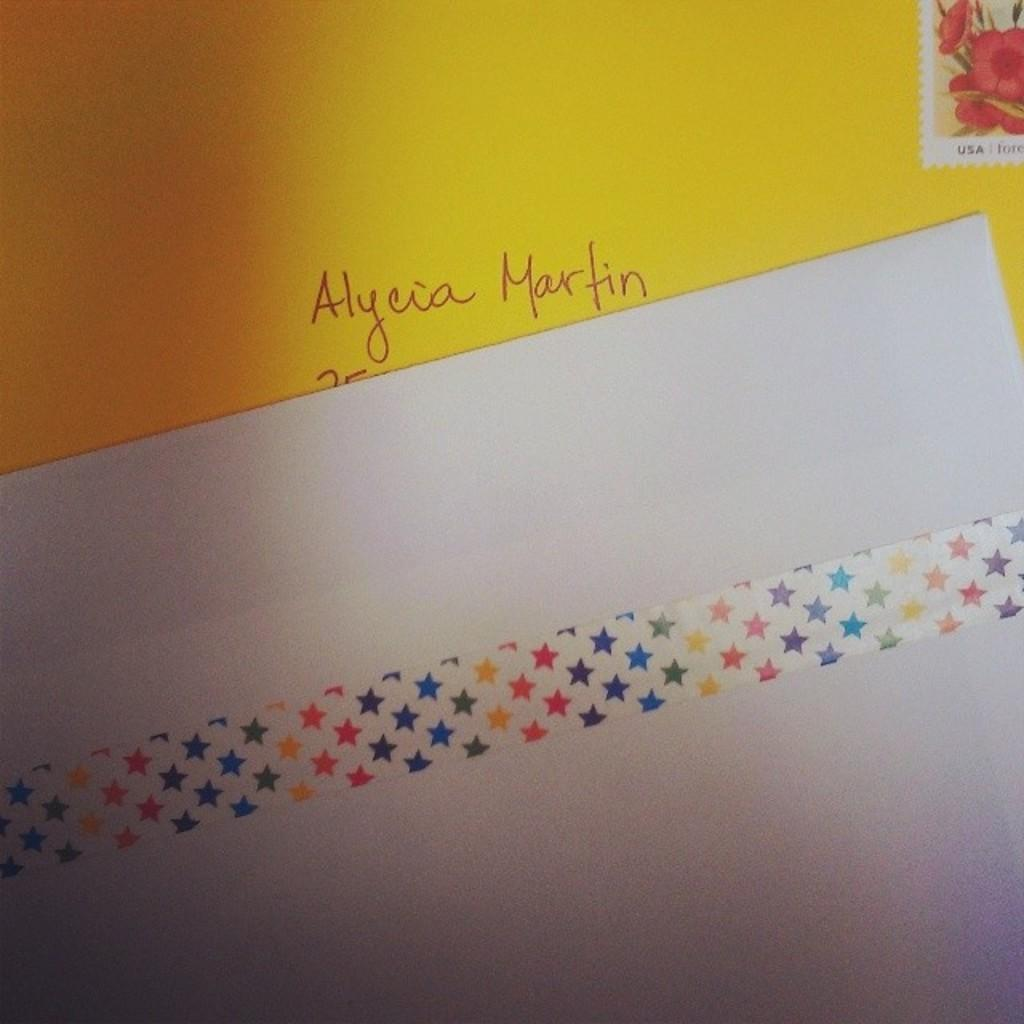<image>
Summarize the visual content of the image. A letter with the word Alycia Martin on it 